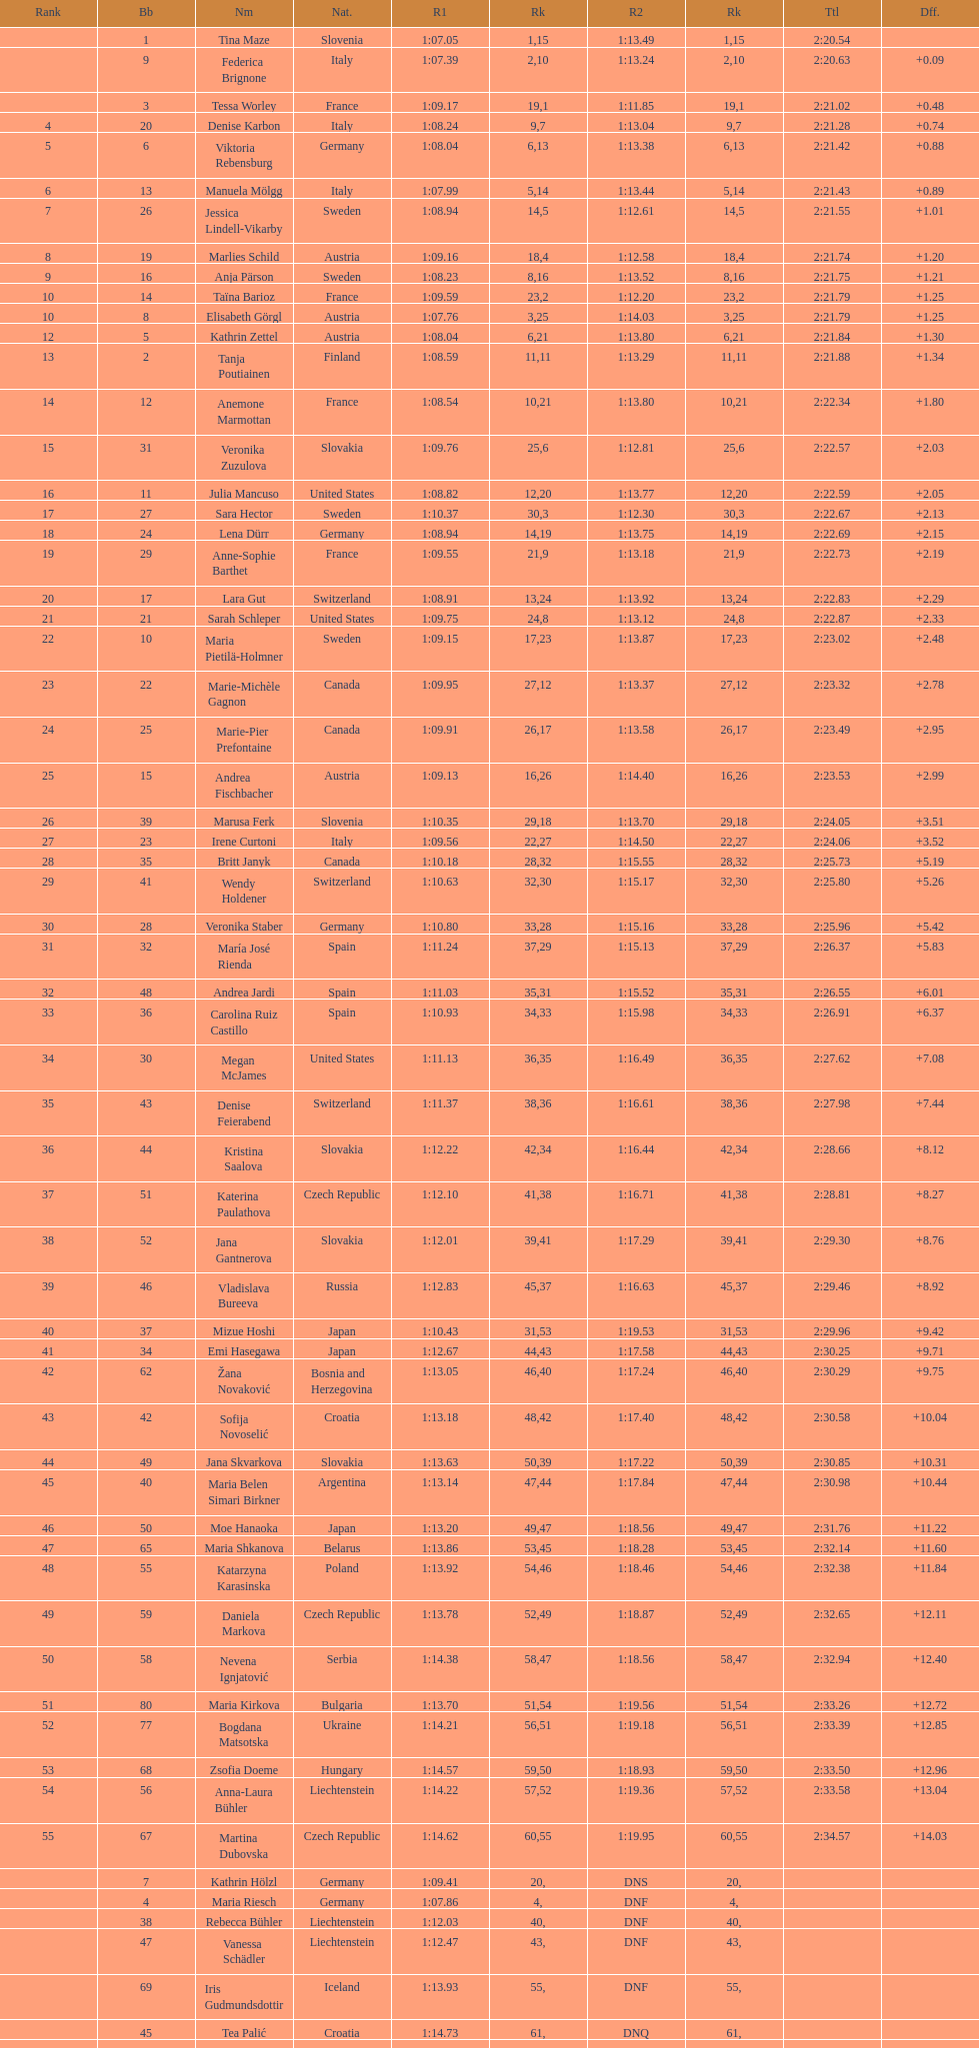Who was the last competitor to actually finish both runs? Martina Dubovska. 